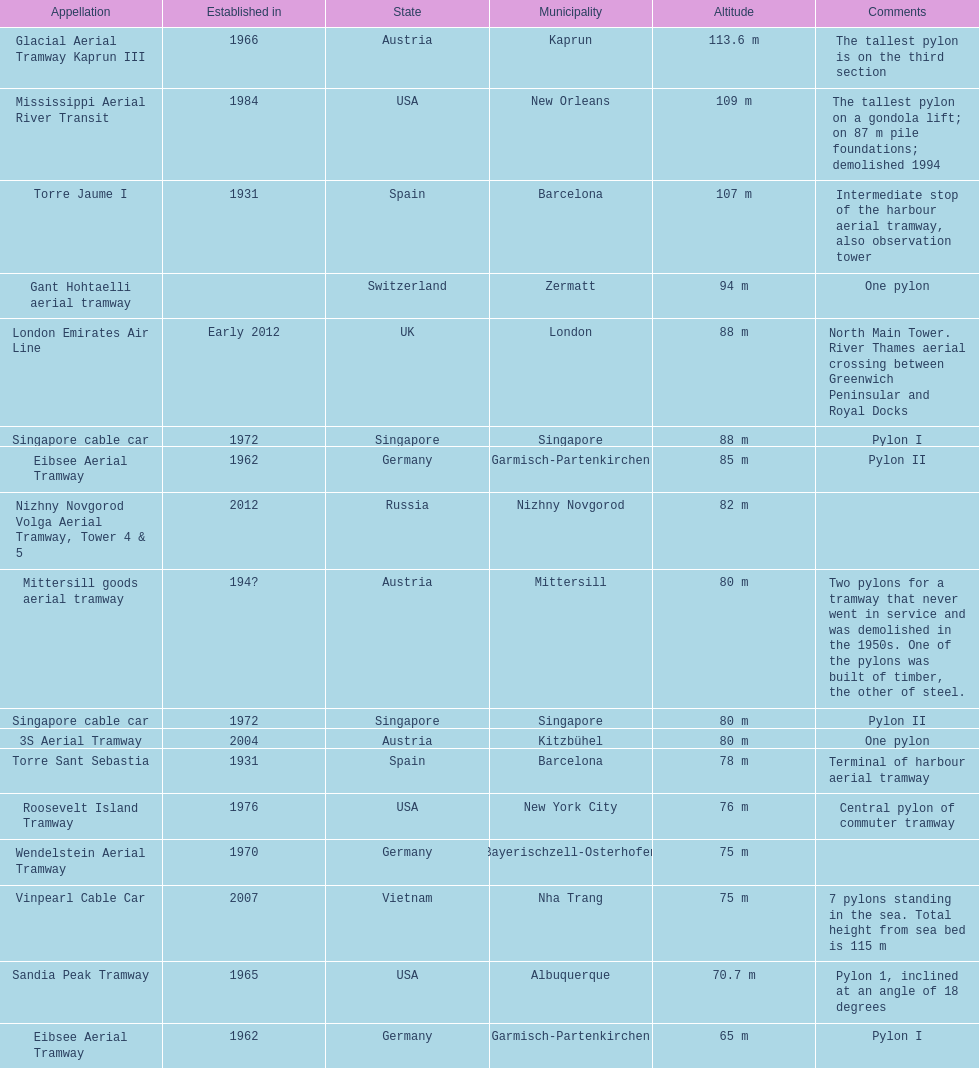Which pylon is the least tall? Eibsee Aerial Tramway. 